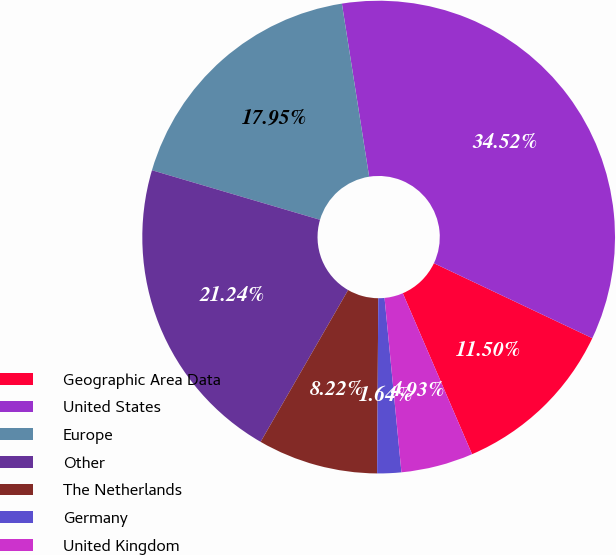Convert chart to OTSL. <chart><loc_0><loc_0><loc_500><loc_500><pie_chart><fcel>Geographic Area Data<fcel>United States<fcel>Europe<fcel>Other<fcel>The Netherlands<fcel>Germany<fcel>United Kingdom<nl><fcel>11.5%<fcel>34.52%<fcel>17.95%<fcel>21.24%<fcel>8.22%<fcel>1.64%<fcel>4.93%<nl></chart> 